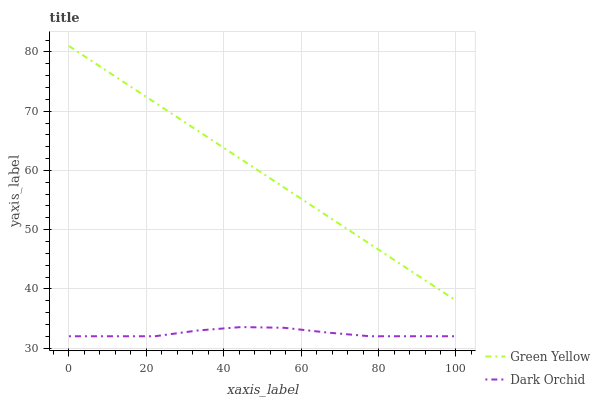Does Dark Orchid have the minimum area under the curve?
Answer yes or no. Yes. Does Green Yellow have the maximum area under the curve?
Answer yes or no. Yes. Does Dark Orchid have the maximum area under the curve?
Answer yes or no. No. Is Green Yellow the smoothest?
Answer yes or no. Yes. Is Dark Orchid the roughest?
Answer yes or no. Yes. Is Dark Orchid the smoothest?
Answer yes or no. No. Does Dark Orchid have the lowest value?
Answer yes or no. Yes. Does Green Yellow have the highest value?
Answer yes or no. Yes. Does Dark Orchid have the highest value?
Answer yes or no. No. Is Dark Orchid less than Green Yellow?
Answer yes or no. Yes. Is Green Yellow greater than Dark Orchid?
Answer yes or no. Yes. Does Dark Orchid intersect Green Yellow?
Answer yes or no. No. 